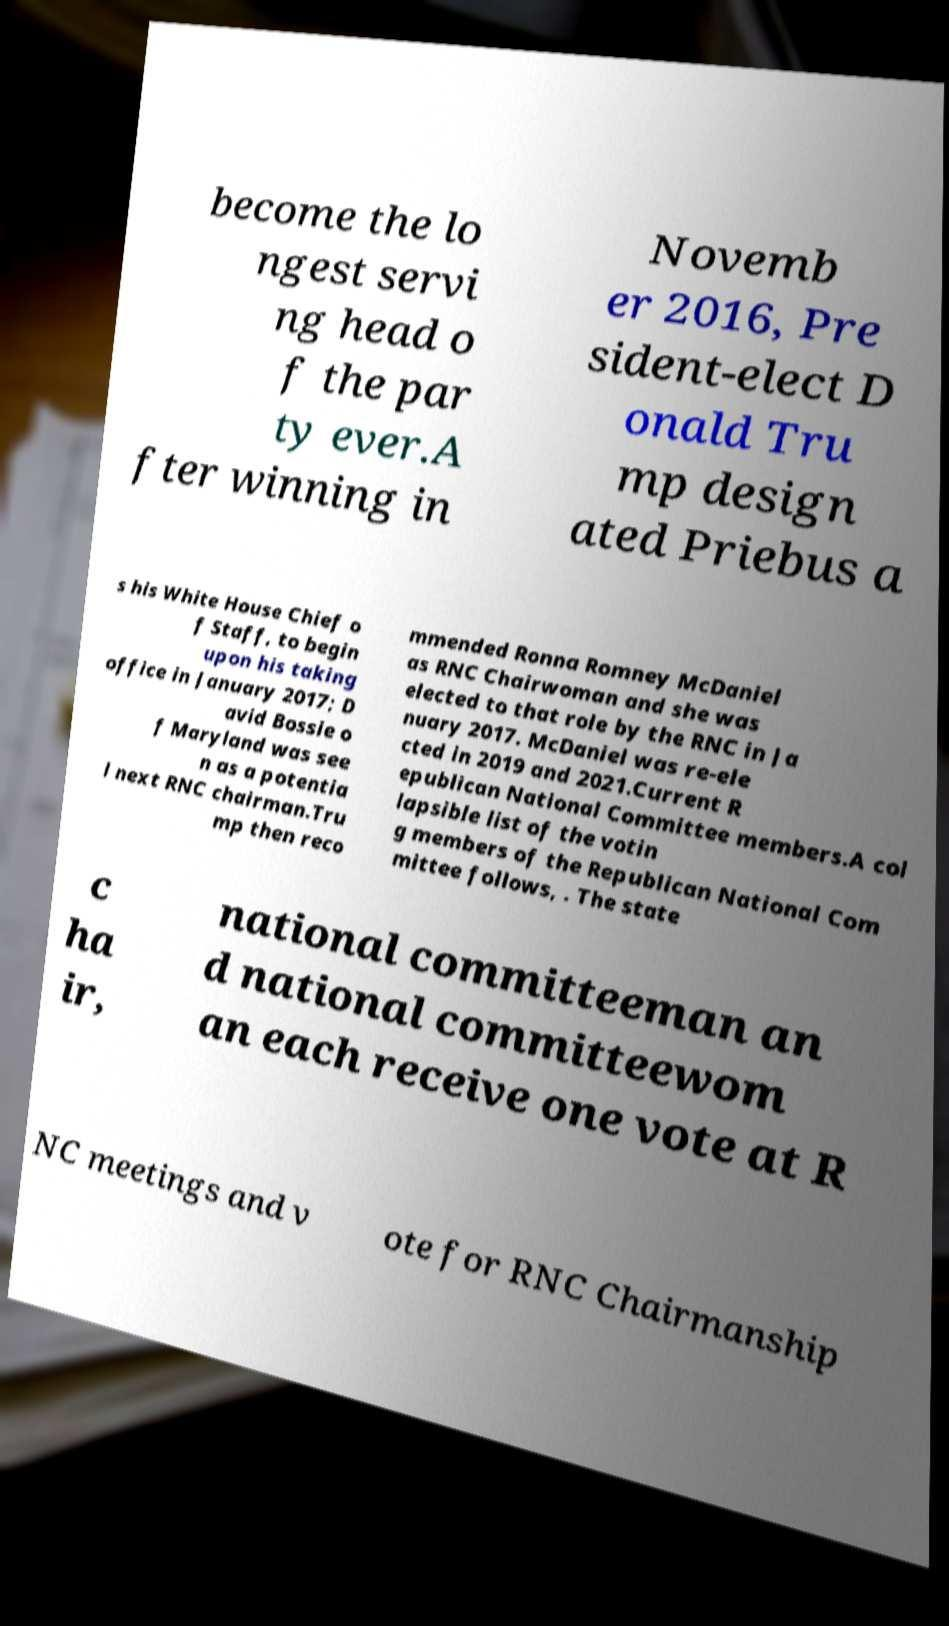Please read and relay the text visible in this image. What does it say? become the lo ngest servi ng head o f the par ty ever.A fter winning in Novemb er 2016, Pre sident-elect D onald Tru mp design ated Priebus a s his White House Chief o f Staff, to begin upon his taking office in January 2017; D avid Bossie o f Maryland was see n as a potentia l next RNC chairman.Tru mp then reco mmended Ronna Romney McDaniel as RNC Chairwoman and she was elected to that role by the RNC in Ja nuary 2017. McDaniel was re-ele cted in 2019 and 2021.Current R epublican National Committee members.A col lapsible list of the votin g members of the Republican National Com mittee follows, . The state c ha ir, national committeeman an d national committeewom an each receive one vote at R NC meetings and v ote for RNC Chairmanship 